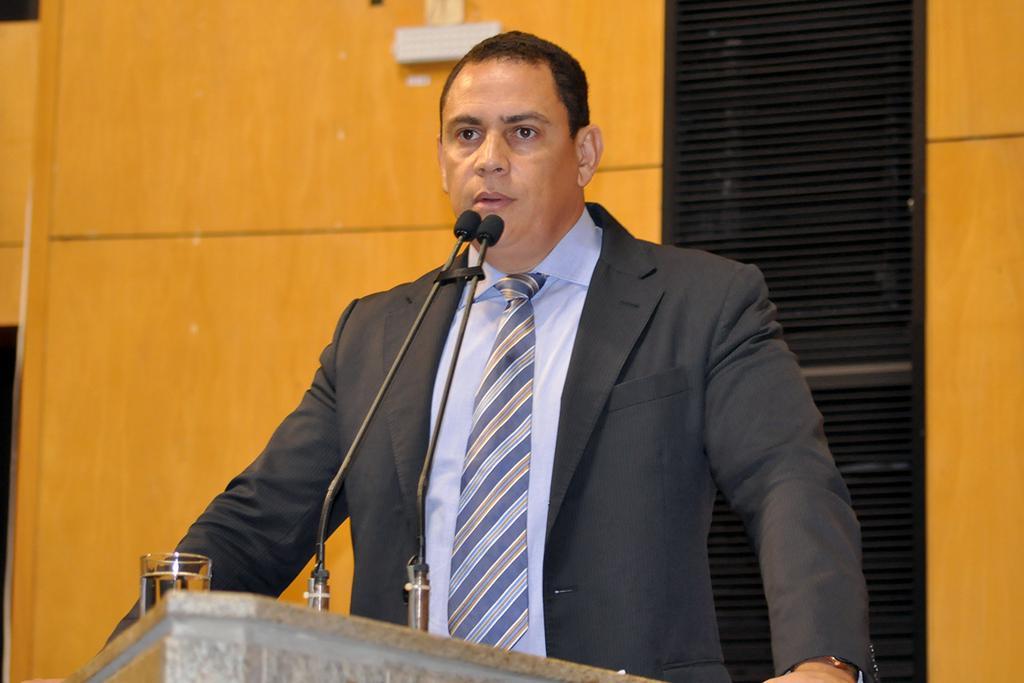How would you summarize this image in a sentence or two? In this image we can see a person standing in front of the podium, on the podium, we can see the mics and a water glass, in the background we can see the wall with some objects. 